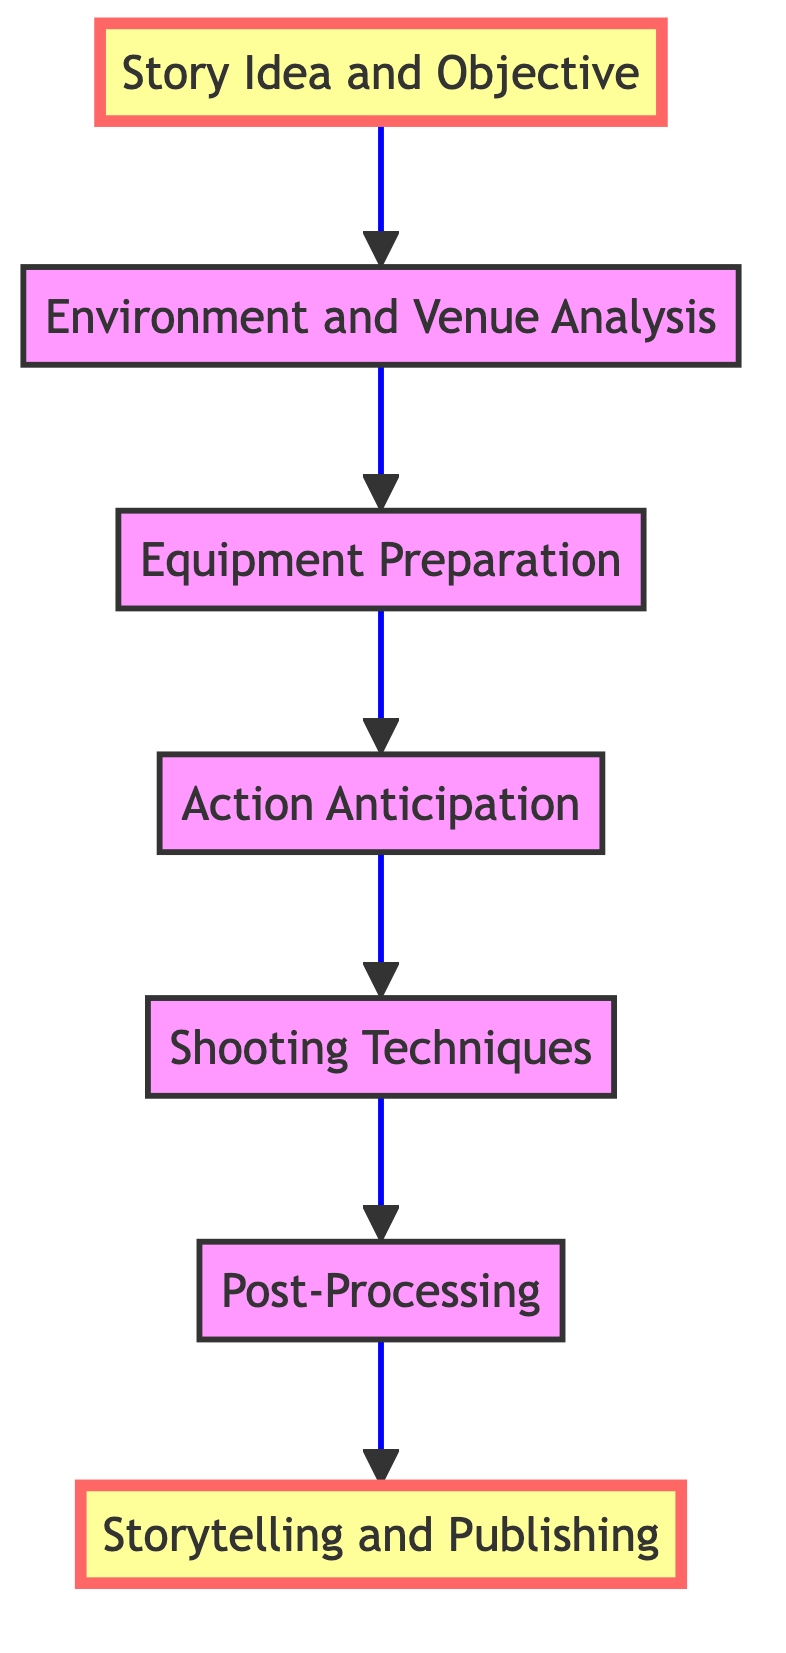What is the first step in the process? The first step in the diagram is "Story Idea and Objective." This is indicated as the bottommost node in the flow chart, which serves as the starting point for capturing a memorable sports image.
Answer: Story Idea and Objective How many nodes are in the diagram? The diagram consists of seven nodes, each representing a different step in the process of capturing a sports image. By counting the distinct elements presented in the diagram, we arrive at this number.
Answer: Seven What is the last step in the process? The last step in the diagram is "Storytelling and Publishing." This node is located at the top of the flow chart, concluding the capturing process.
Answer: Storytelling and Publishing What follows "Shooting Techniques"? The node that follows "Shooting Techniques" is "Post-Processing." This is determined by following the arrow that indicates the progression from one step to the next in the flow chart.
Answer: Post-Processing What is the relationship between "Environment and Venue Analysis" and "Equipment Preparation"? "Environment and Venue Analysis" leads to "Equipment Preparation," indicating that the latter step relies on insights gained from the former. The flow chart shows a directional arrow connecting these two nodes, illustrating this sequential relationship.
Answer: Leads to What is the purpose of "Action Anticipation"? The purpose of "Action Anticipation" is to understand the sport well enough to predict key moments, enabling the photographer to position themselves effectively. This is derived from the description provided with this node in the diagram.
Answer: Predict key moments What is the flow direction in the diagram? The flow direction in the diagram is from bottom to top. This means the process starts at the bottom with the first step and progresses upward toward the final output at the top, visualized through the connecting arrows.
Answer: Bottom to top Which step involves editing captured images? The step that involves editing captured images is "Post-Processing." This is clearly indicated within the diagram, highlighting its relevance in the technical and creative process.
Answer: Post-Processing What technique is utilized during "Shooting Techniques"? Techniques such as panning, continuous shooting, and managing shutter speed are utilized during "Shooting Techniques." This information is contained in the description of the node, indicating the specific practices involved at this stage.
Answer: Panning, continuous shooting, shutter speed 